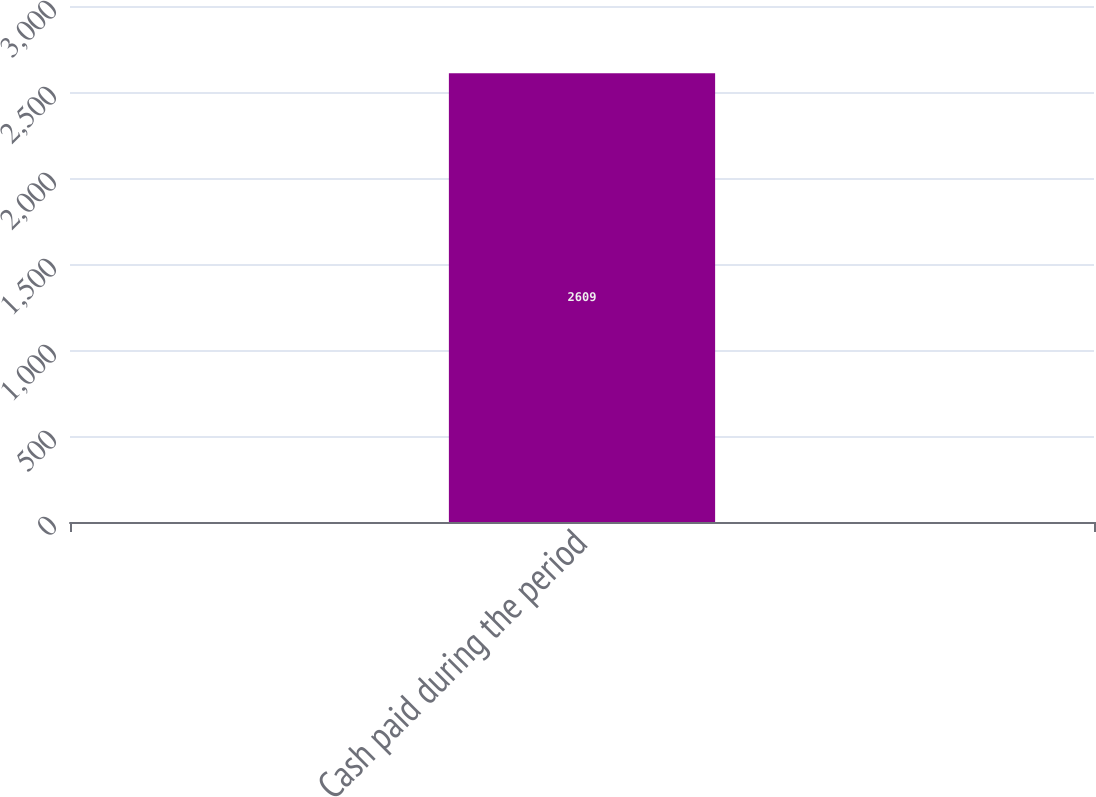Convert chart to OTSL. <chart><loc_0><loc_0><loc_500><loc_500><bar_chart><fcel>Cash paid during the period<nl><fcel>2609<nl></chart> 